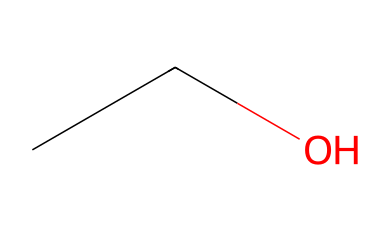How many carbon atoms are in the ethanol structure? The SMILES representation "CCO" indicates there are two 'C' atoms present, which represents the carbon atoms in the structure.
Answer: 2 What is the functional group present in ethanol? Analyzing the SMILES "CCO," the 'O' at the end denotes the presence of an alcohol functional group (-OH), characterizing ethanol.
Answer: alcohol What is the molecular formula for ethanol? From the SMILES "CCO," we can deduce the molecular formula by counting the atoms: 2 carbons (C), 6 hydrogens (H), and 1 oxygen (O), forming C2H6O.
Answer: C2H6O Which type of compound is ethanol classified as? Ethanol, represented as "CCO," is identified with a simple structure that contains carbon chains and an alcohol group, categorizing it as an aliphatic compound.
Answer: aliphatic What type of isomerism can ethanol exhibit? Ethanol ("CCO") can show structural isomerism because there are other compounds with the same molecular formula (C2H6O) but different structures and properties, like dimethyl ether.
Answer: structural isomerism What is the primary use of ethanol in beverages? The structure of ethanol indicates it is commonly used as an alcoholic beverage ingredient, as it is the active ingredient in drinks that produce intoxication at festivals.
Answer: intoxication 